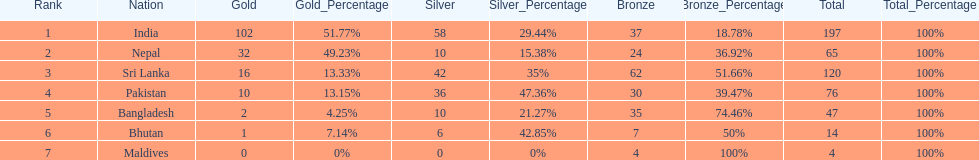What countries attended the 1999 south asian games? India, Nepal, Sri Lanka, Pakistan, Bangladesh, Bhutan, Maldives. Which of these countries had 32 gold medals? Nepal. 